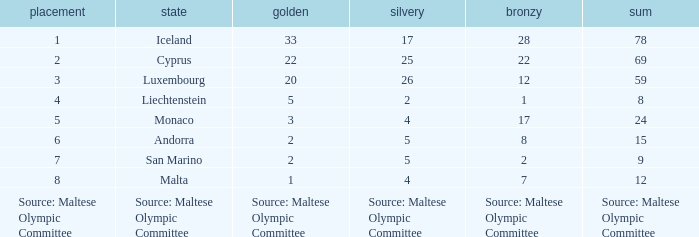What rank is the nation with 2 silver medals? 4.0. 